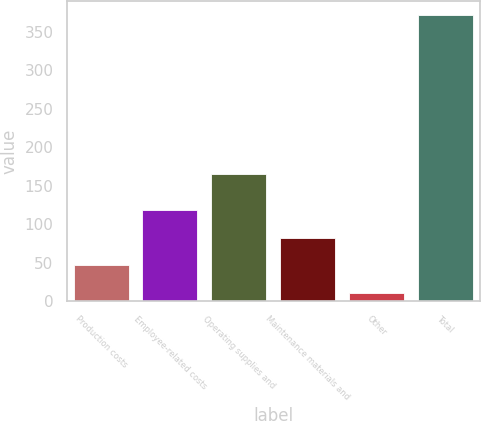Convert chart to OTSL. <chart><loc_0><loc_0><loc_500><loc_500><bar_chart><fcel>Production costs<fcel>Employee-related costs<fcel>Operating supplies and<fcel>Maintenance materials and<fcel>Other<fcel>Total<nl><fcel>46.2<fcel>118.6<fcel>165<fcel>82.4<fcel>10<fcel>372<nl></chart> 